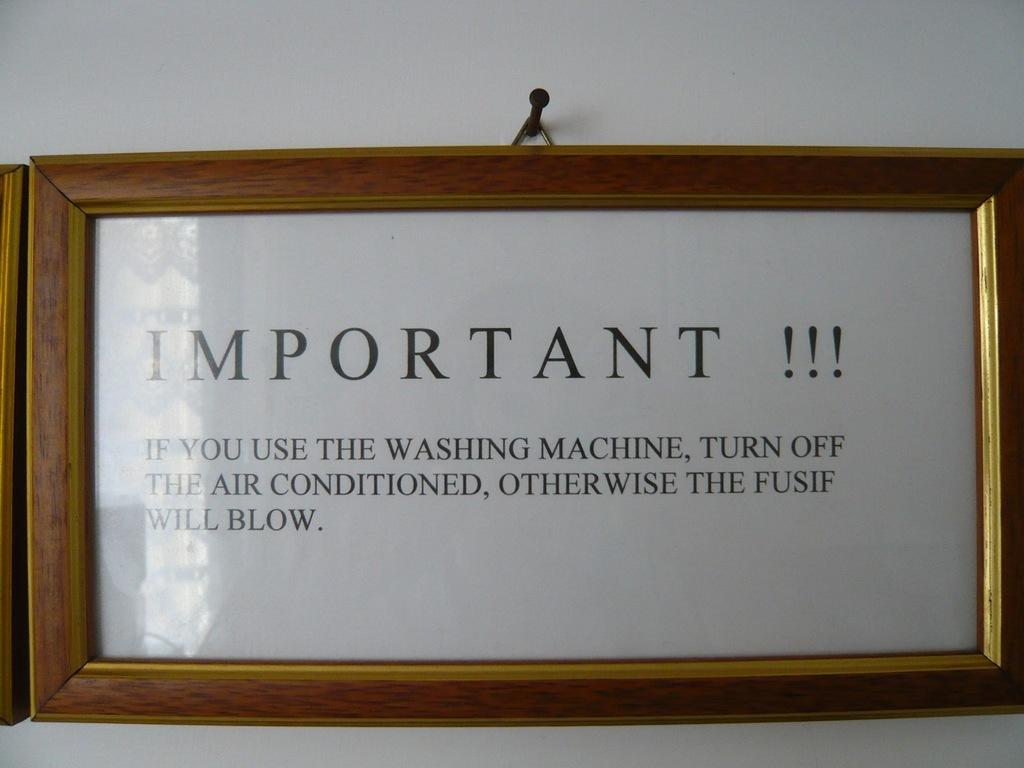<image>
Create a compact narrative representing the image presented. A wooden framed sign hangs on the wall making sure people turn off the washing machine when they are done with it. 